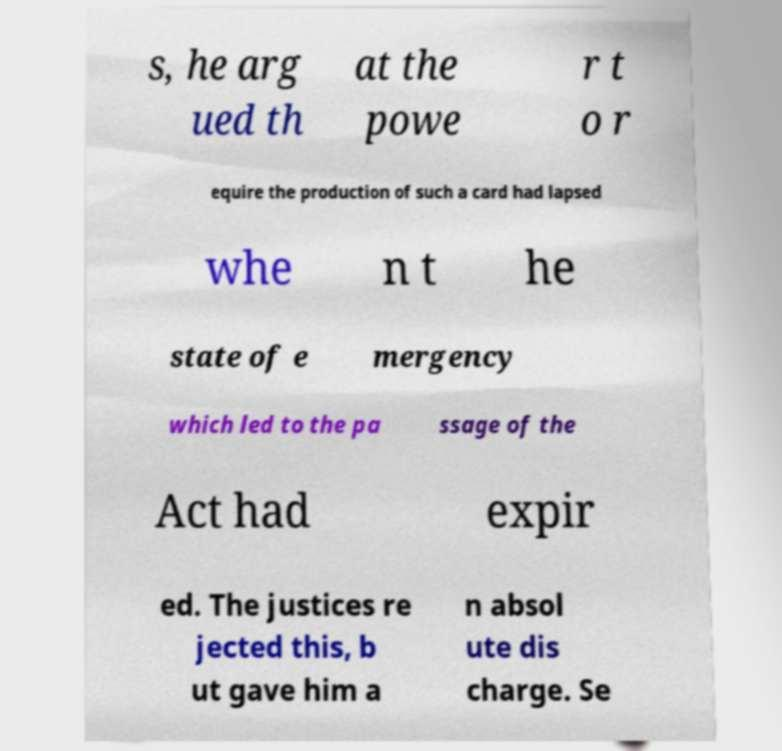Please read and relay the text visible in this image. What does it say? s, he arg ued th at the powe r t o r equire the production of such a card had lapsed whe n t he state of e mergency which led to the pa ssage of the Act had expir ed. The justices re jected this, b ut gave him a n absol ute dis charge. Se 